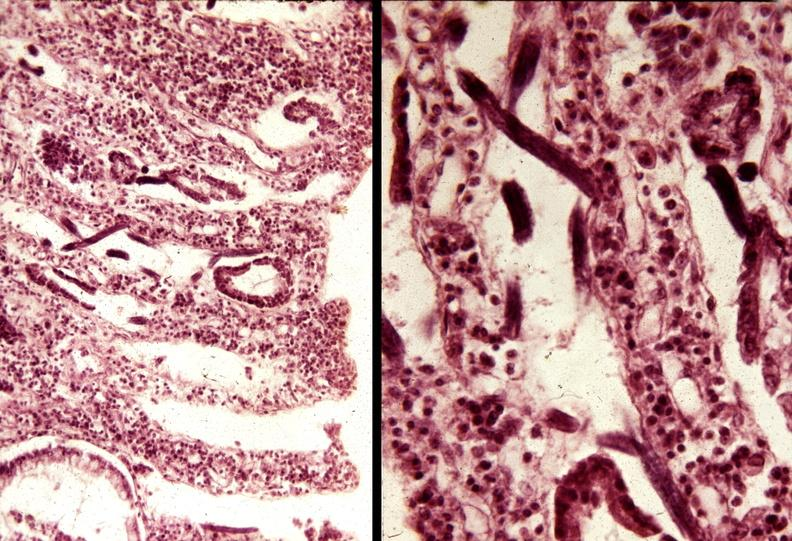does subdiaphragmatic abscess show colon, strongyloidiasis?
Answer the question using a single word or phrase. No 